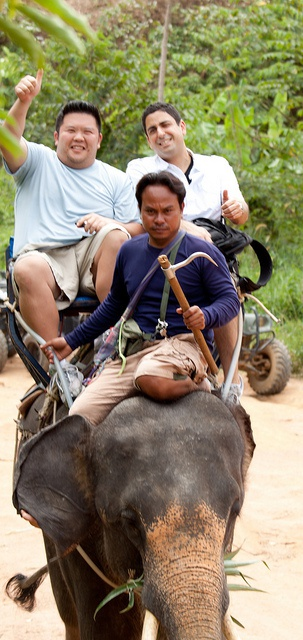Describe the objects in this image and their specific colors. I can see elephant in olive, black, and gray tones, people in olive, black, navy, brown, and gray tones, people in olive, lightgray, salmon, and tan tones, people in olive, white, tan, brown, and gray tones, and backpack in olive, black, gray, and darkgreen tones in this image. 